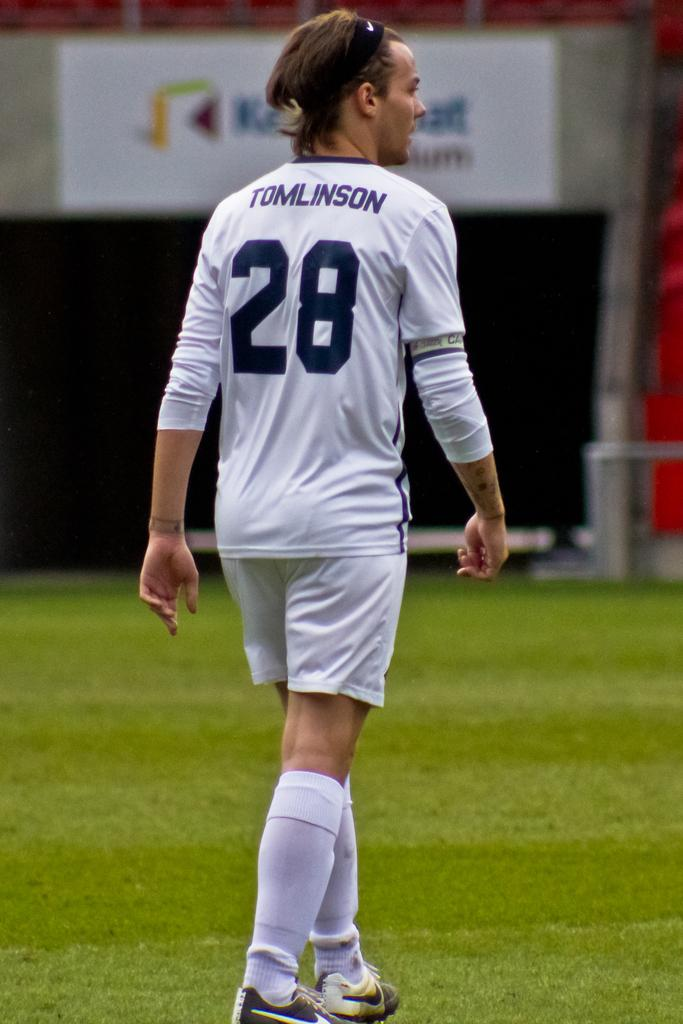<image>
Share a concise interpretation of the image provided. Soccer player wearing a jersey which says Tomlinson on it. 